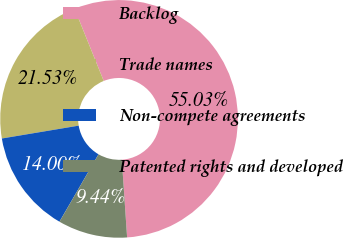Convert chart. <chart><loc_0><loc_0><loc_500><loc_500><pie_chart><fcel>Backlog<fcel>Trade names<fcel>Non-compete agreements<fcel>Patented rights and developed<nl><fcel>55.03%<fcel>21.53%<fcel>14.0%<fcel>9.44%<nl></chart> 